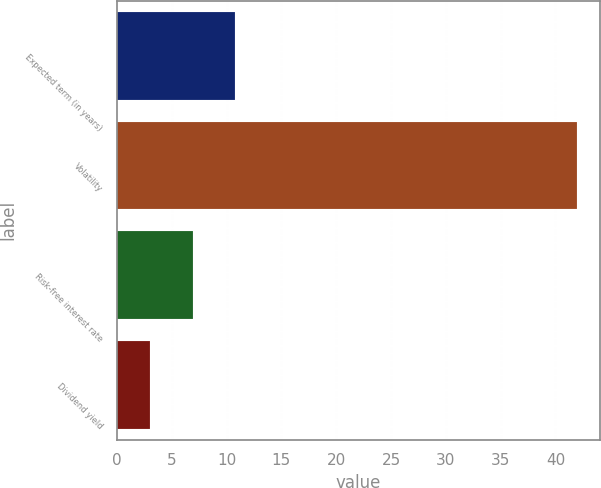Convert chart to OTSL. <chart><loc_0><loc_0><loc_500><loc_500><bar_chart><fcel>Expected term (in years)<fcel>Volatility<fcel>Risk-free interest rate<fcel>Dividend yield<nl><fcel>10.81<fcel>42<fcel>6.91<fcel>3.01<nl></chart> 